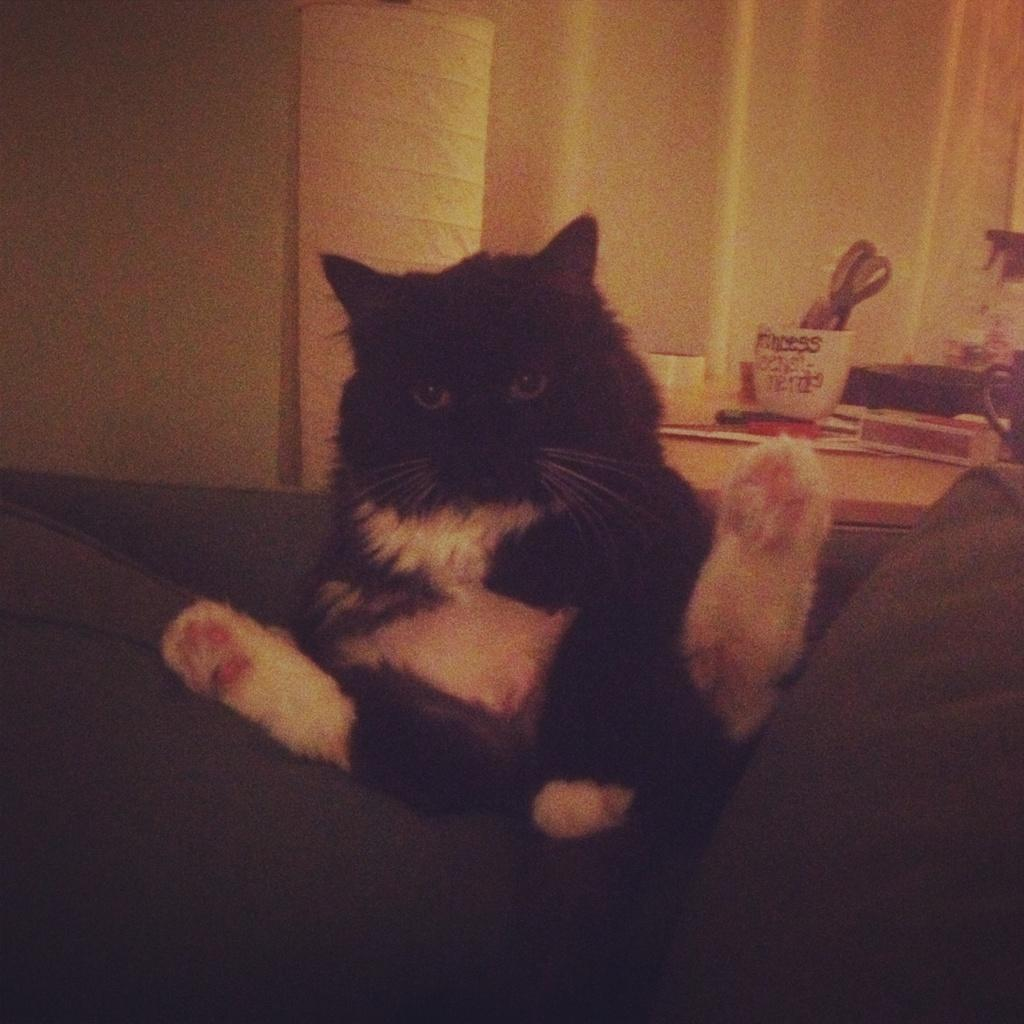What animal is present in the image? There is a cat in the image. What color is the cat? The cat is white and black in color. Where is the cat located in the image? The cat is on a grey surface. What can be seen in the background of the image? There is a table in the background of the image. What items are on the table? There is a cup, scissors, and other objects on the table. What type of chin is visible on the cat in the image? There is no chin visible on the cat in the image, as it is a photograph of the cat's body and not its face. 